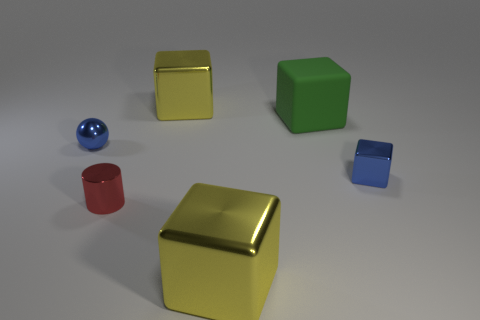Can you describe the texture and color of the objects closest to the front of the image? The objects closest to the front of the image are two cubes. The one directly in front has a shiny, reflective golden-yellow surface, indicating a smooth and possibly metallic texture. The cube slightly to the right and behind the first is red with a more matte finish, suggesting a less reflective and possibly painted or plastic texture. 